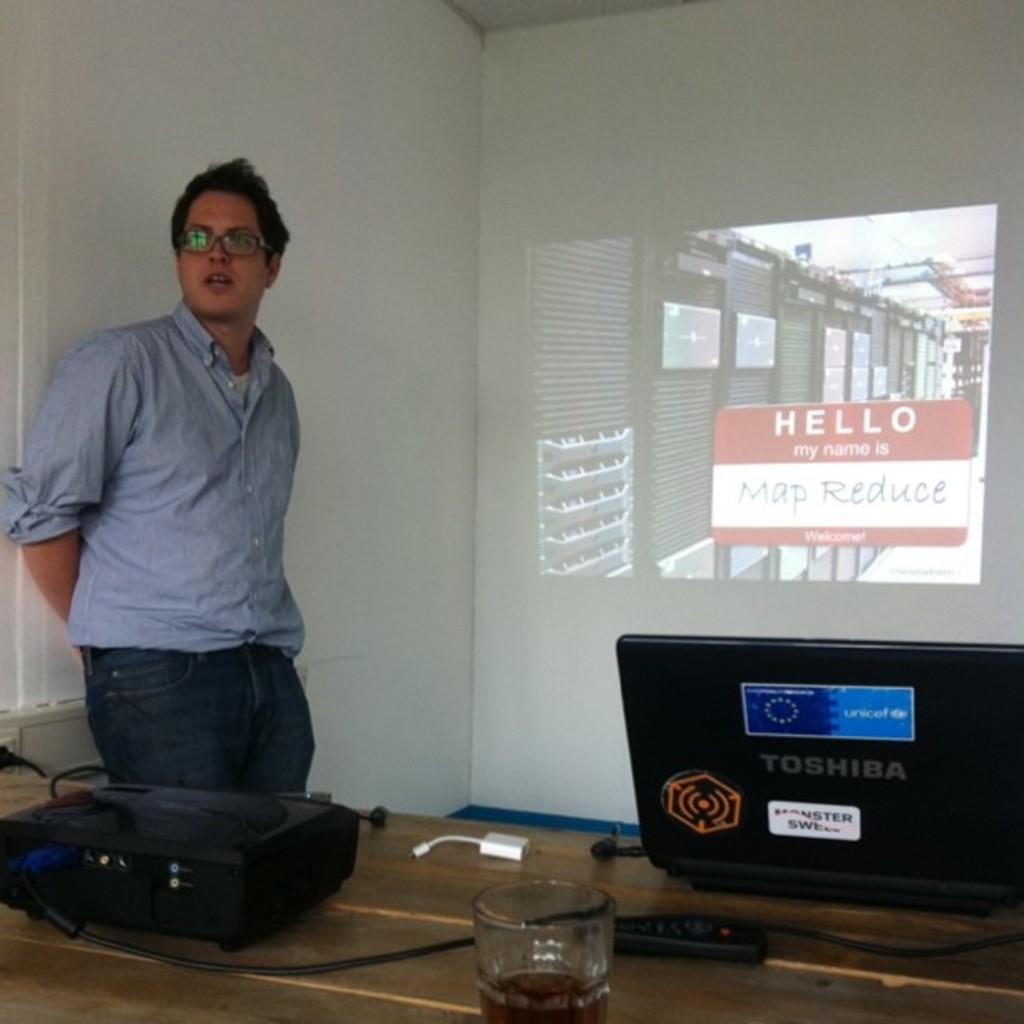Can you describe this image briefly? On the left side of the image we can see a man standing. At the bottom there is a table and we can see a projector, laptop, glass and a remote place on the table. In the background there is a wall and we can see a screen. 